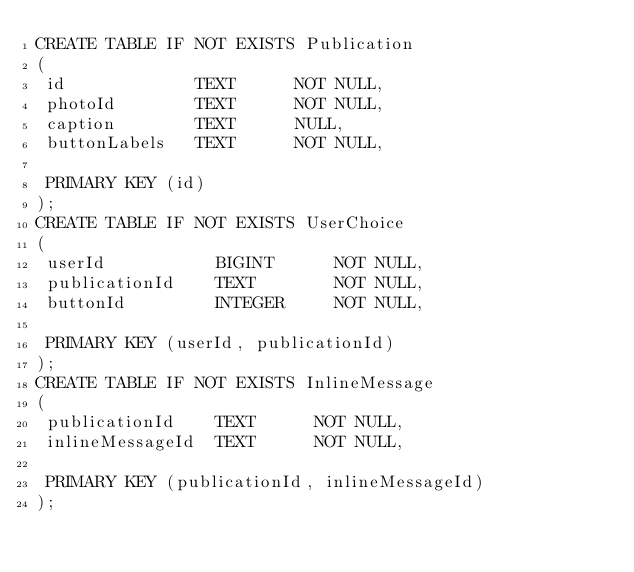Convert code to text. <code><loc_0><loc_0><loc_500><loc_500><_SQL_>CREATE TABLE IF NOT EXISTS Publication
(
 id             TEXT      NOT NULL,
 photoId        TEXT      NOT NULL,
 caption        TEXT      NULL,
 buttonLabels   TEXT      NOT NULL,

 PRIMARY KEY (id)
);
CREATE TABLE IF NOT EXISTS UserChoice
(
 userId           BIGINT      NOT NULL,
 publicationId    TEXT        NOT NULL,
 buttonId         INTEGER     NOT NULL,

 PRIMARY KEY (userId, publicationId)
);
CREATE TABLE IF NOT EXISTS InlineMessage
(
 publicationId    TEXT      NOT NULL,
 inlineMessageId  TEXT      NOT NULL,

 PRIMARY KEY (publicationId, inlineMessageId)
);
</code> 